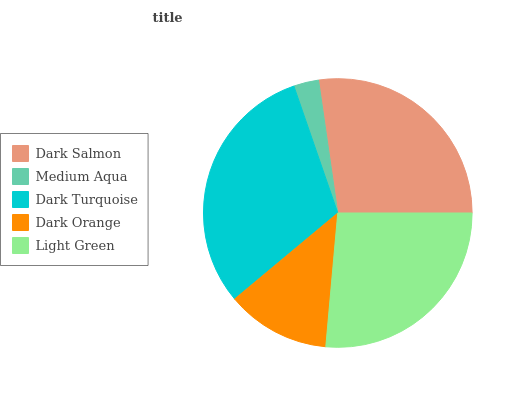Is Medium Aqua the minimum?
Answer yes or no. Yes. Is Dark Turquoise the maximum?
Answer yes or no. Yes. Is Dark Turquoise the minimum?
Answer yes or no. No. Is Medium Aqua the maximum?
Answer yes or no. No. Is Dark Turquoise greater than Medium Aqua?
Answer yes or no. Yes. Is Medium Aqua less than Dark Turquoise?
Answer yes or no. Yes. Is Medium Aqua greater than Dark Turquoise?
Answer yes or no. No. Is Dark Turquoise less than Medium Aqua?
Answer yes or no. No. Is Light Green the high median?
Answer yes or no. Yes. Is Light Green the low median?
Answer yes or no. Yes. Is Dark Salmon the high median?
Answer yes or no. No. Is Dark Salmon the low median?
Answer yes or no. No. 